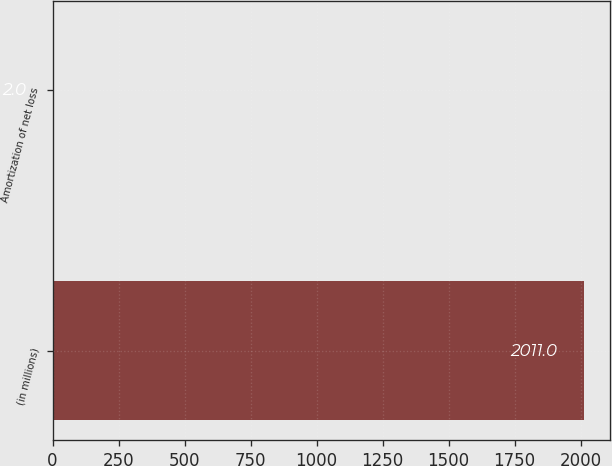<chart> <loc_0><loc_0><loc_500><loc_500><bar_chart><fcel>(in millions)<fcel>Amortization of net loss<nl><fcel>2011<fcel>2<nl></chart> 